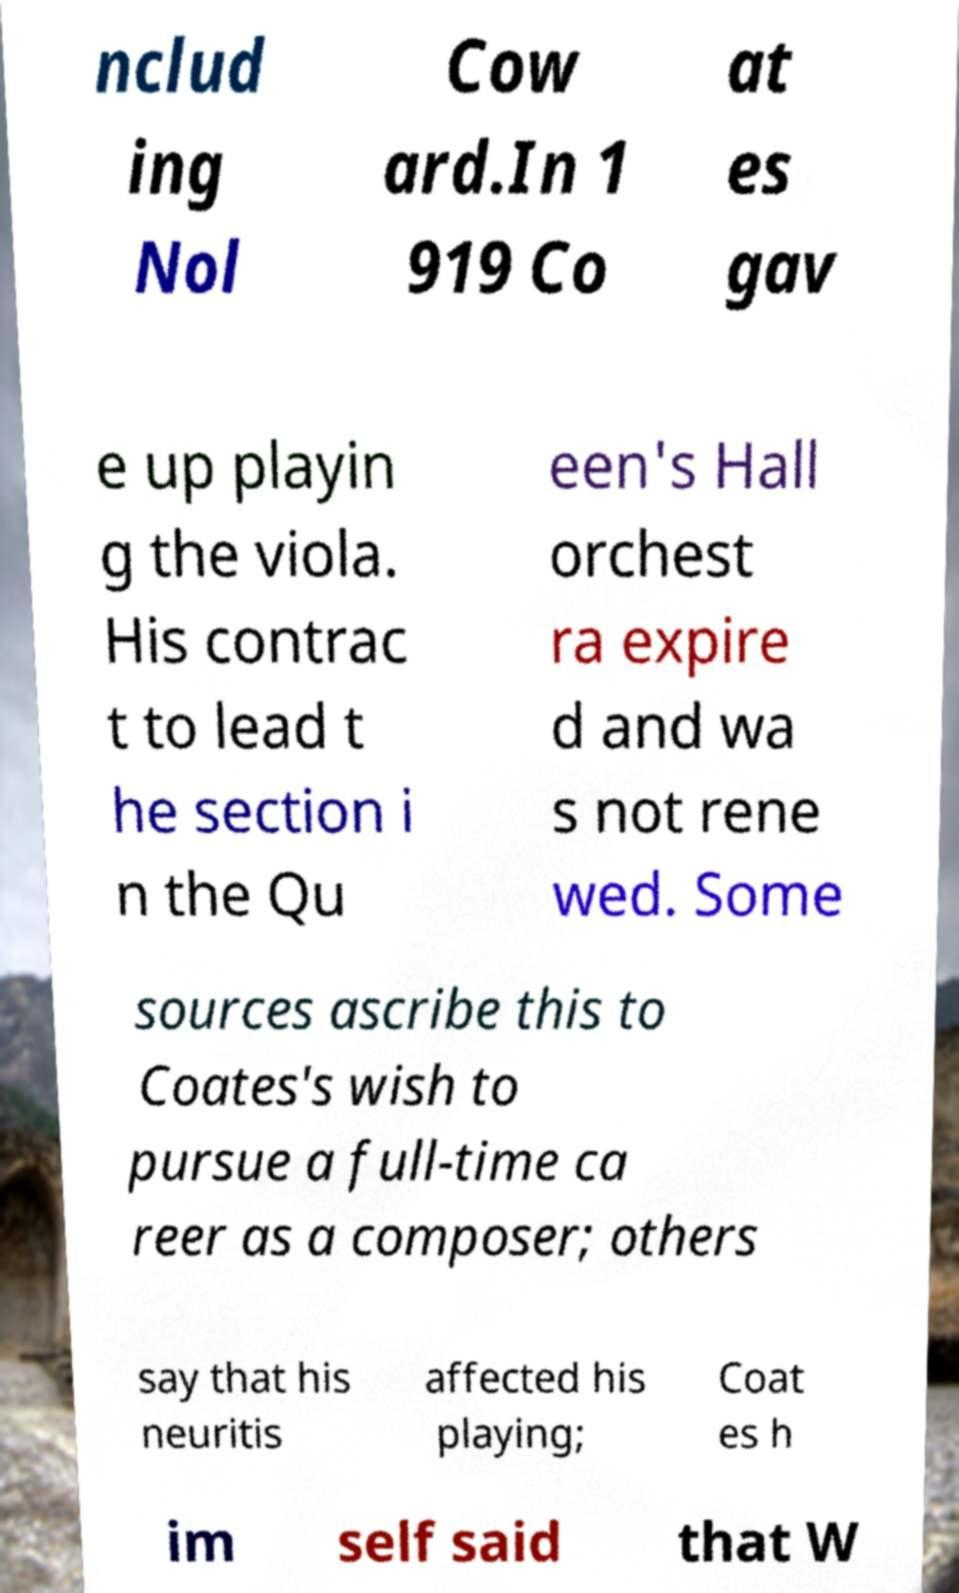I need the written content from this picture converted into text. Can you do that? nclud ing Nol Cow ard.In 1 919 Co at es gav e up playin g the viola. His contrac t to lead t he section i n the Qu een's Hall orchest ra expire d and wa s not rene wed. Some sources ascribe this to Coates's wish to pursue a full-time ca reer as a composer; others say that his neuritis affected his playing; Coat es h im self said that W 